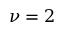<formula> <loc_0><loc_0><loc_500><loc_500>\nu = 2</formula> 